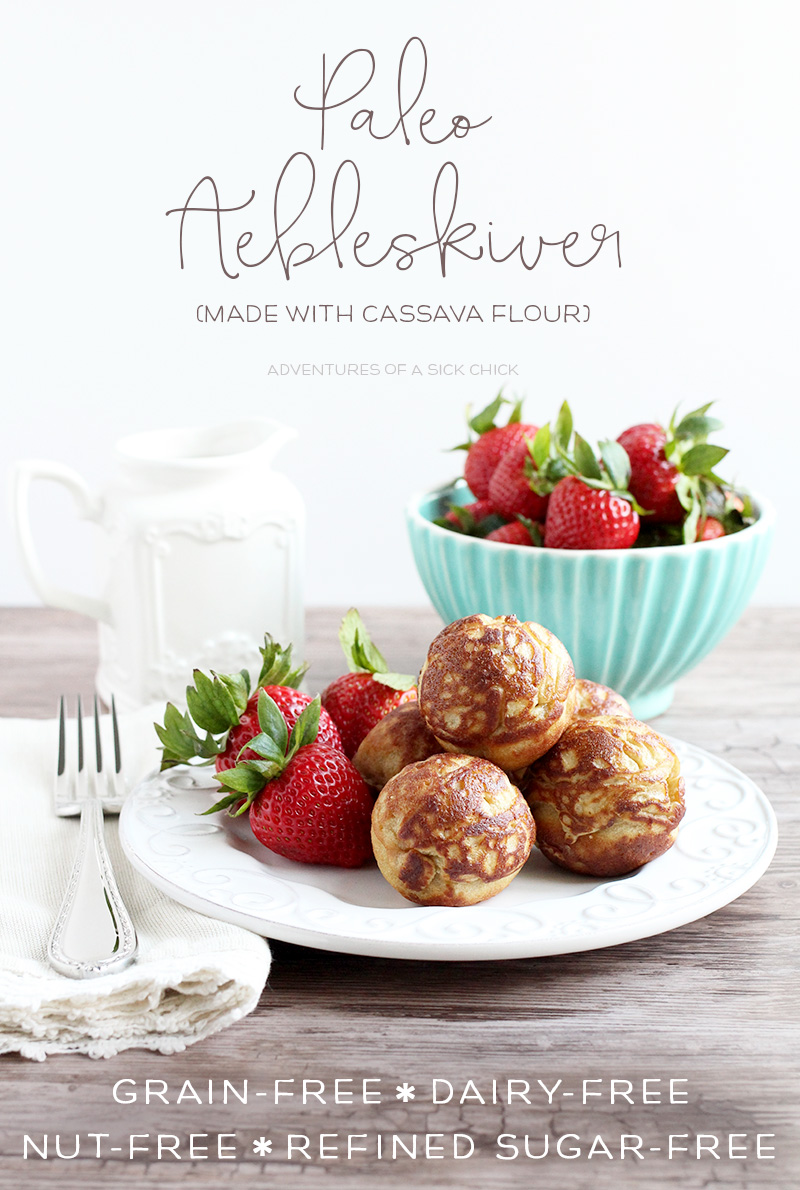If these pastries were to be marketed in a grocery store, what unique selling points might be highlighted to attract potential buyers? If these pastries were to be marketed in a grocery store, several unique selling points could be highlighted to attract health-conscious buyers: 

1. **100% Grain-Free:** Perfect for those avoiding grains or following a Paleo diet, ensuring no compromise on dietary preferences.
2. **Gluten-Free:** Safe for individuals with celiac disease or gluten sensitivities, providing an inclusive option for all consumers.
3. **Dairy-Free and Nut-Free:** Catering to those with allergies or dietary restrictions related to dairy and nuts, making it a safe choice for various dietary needs.
4. **Refined Sugar-Free:** Sweetened naturally without refined sugars, appealing to those monitoring their sugar intake for weight management or health reasons.
5. **Versatile Baking Ingredient:** Highlighting that cassava flour is used to achieve a fluffy, light texture while maintaining a neutral taste, perfect for diverse culinary applications.
6. **Health Benefits:** Rich in resistant starch, aiding in digestive health and promoting a healthy gut microbiome.
7. **Artisanal Quality:** Emphasizing the artisanal preparation process, which could appeal to consumers looking for gourmet, high-quality food products.

By focusing on these selling points, potential buyers would understand the health benefits and dietary compatibility of the product, boosting its appeal in a grocery store setting. Create a fantastical story surrounding these pastries, something imaginative to captivate children and adults alike. In a quaint village hidden within an enchanted forest, there existed a magical bakery known as ‘The Flourished Faerie.” This bakery was renowned for its mystical pastries made from ingredients sourced from the most mystical corners of the kingdom. Among its treasures were the famed Paleo æbleskiver, made with cassava flour rumored to be harvested under the full moon by sprites. 

Legend had it that these enchanted pastries held the power to grant temporary wings to those who ate them, allowing villagers to experience the joy of flight and explore the hidden wonders of the forest. Children and adults alike would gather at the break of dawn, hoping to catch a glimpse of the faeries in action and taste the magical treat that promised adventure. The bakery's charm was not just in its food but in the stories that swirled around its creation, with every bite promising a piece of the enchanted tale. Past the bakery’s stone archways, a realm of imagination flourished, where tasting an æbleskiver meant embarking on a fantastical journey beyond the ordinary world. 